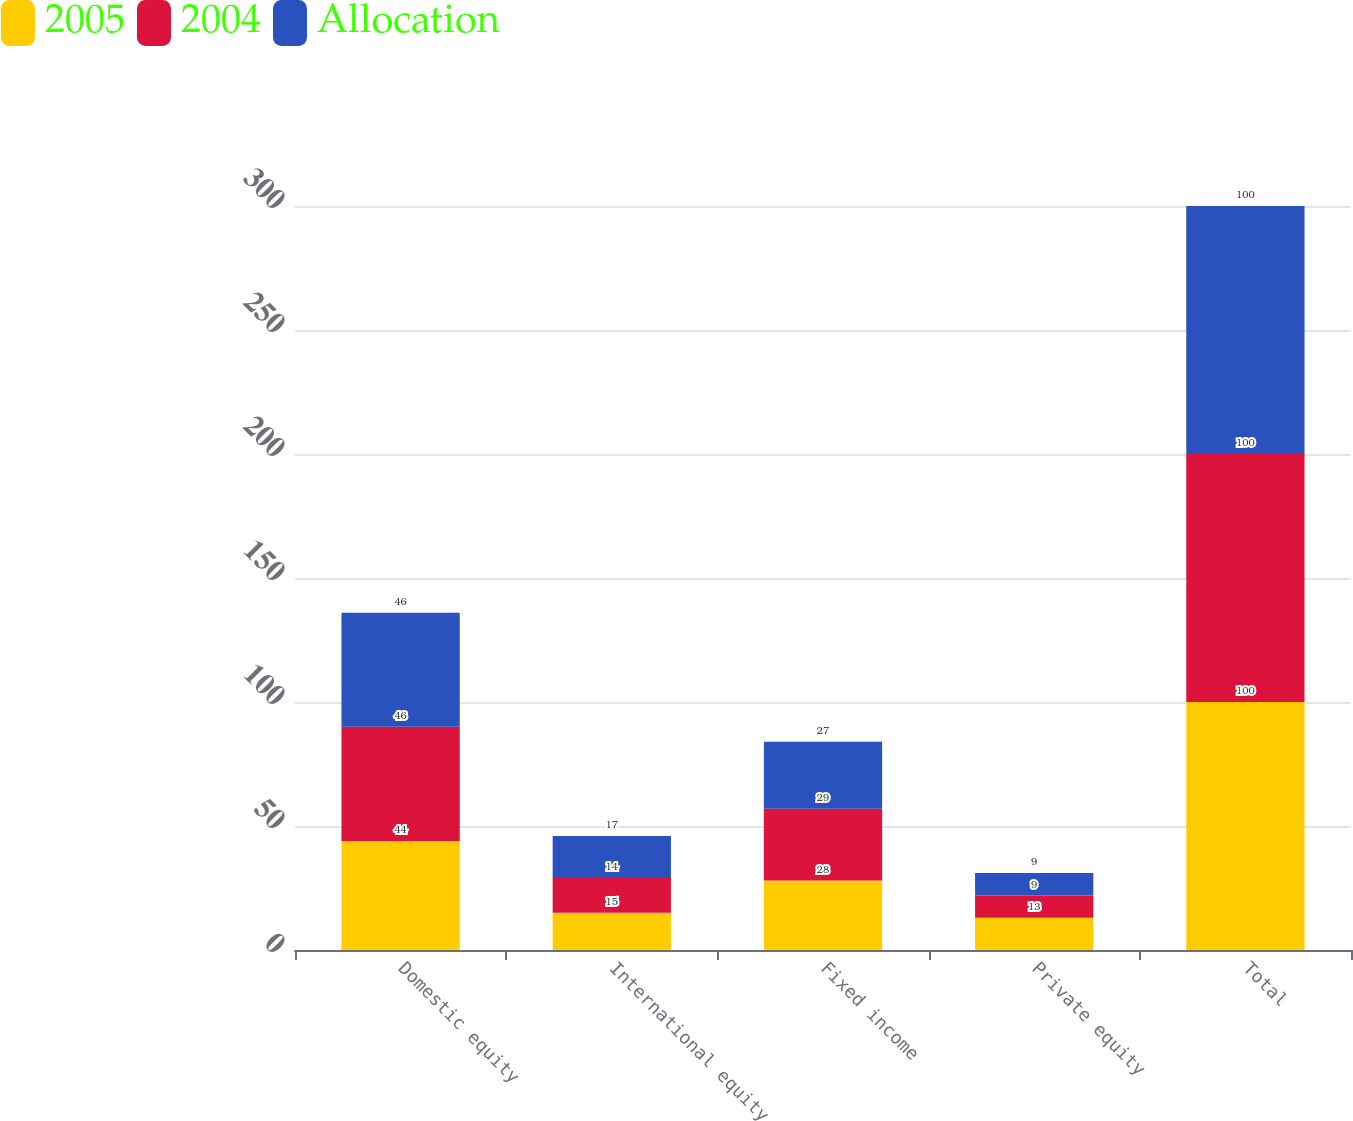Convert chart to OTSL. <chart><loc_0><loc_0><loc_500><loc_500><stacked_bar_chart><ecel><fcel>Domestic equity<fcel>International equity<fcel>Fixed income<fcel>Private equity<fcel>Total<nl><fcel>2005<fcel>44<fcel>15<fcel>28<fcel>13<fcel>100<nl><fcel>2004<fcel>46<fcel>14<fcel>29<fcel>9<fcel>100<nl><fcel>Allocation<fcel>46<fcel>17<fcel>27<fcel>9<fcel>100<nl></chart> 